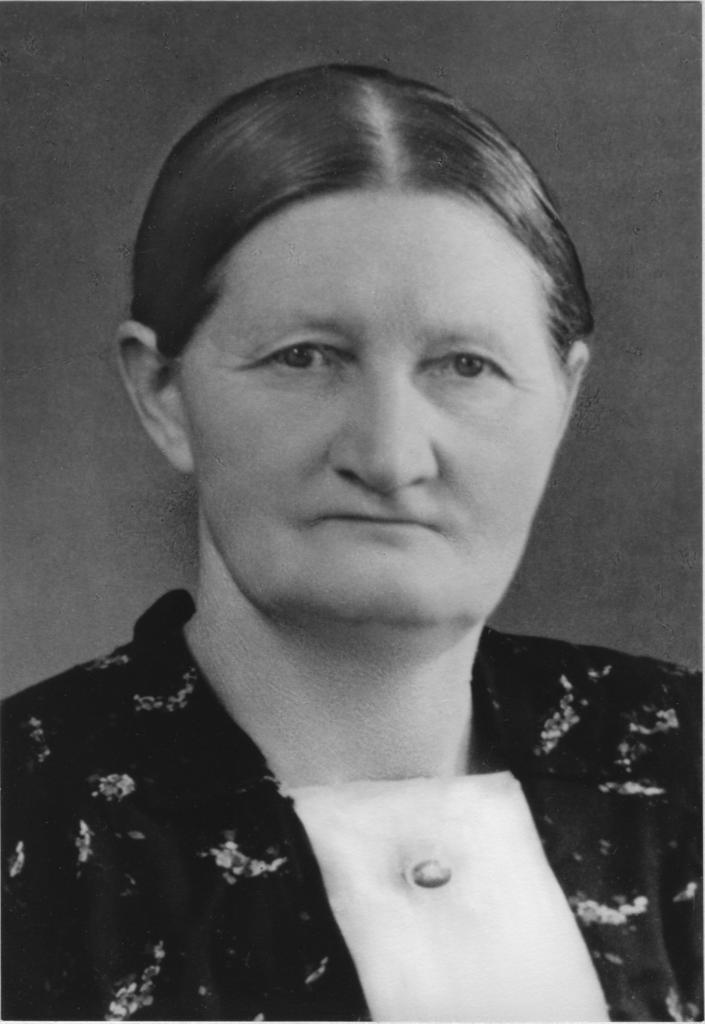What is the color scheme of the photograph? The photograph is black and white. Who is the main subject in the photograph? There is a woman in the photograph. What is the woman wearing in the photograph? The woman is wearing a black dress. What can be seen behind the woman in the photograph? There is a wall visible behind the woman. What time of day does the maid appear in the photograph? There is no maid present in the photograph, and therefore no specific time of day can be determined. 